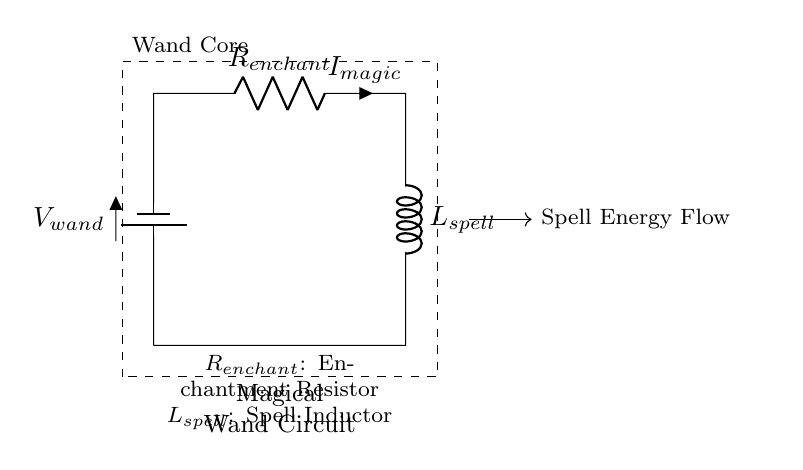What is the voltage source in this circuit? The voltage source is labeled as V_wand, which indicates it is providing the electrical potential to the circuit for creating magical effects.
Answer: V_wand What component is represented by R in the circuit? The component R is labeled as R_enchant, which denotes it as the Enchantment Resistor that contributes to the magical properties of the circuit.
Answer: R_enchant What is the current flowing through the resistor? The current flowing through the resistor is labeled as I_magic, indicating it is the current responsible for the enchanting effects within the wand.
Answer: I_magic What is the purpose of the inductor in this circuit? The inductor, labeled as L_spell, is used to store energy in the form of a magnetic field and release it subsequently, crucial for the functionality of magical spells.
Answer: L_spell How are the resistor and inductor connected in the circuit? The resistor R_enchant is connected in series with the inductor L_spell, creating a path for the current to flow and interact in a way that enables the special effects of the wand.
Answer: Series What is the total energy flow in the circuit represented by? The total energy flow is represented by the dashed arrow labeled as Spell Energy Flow, indicating the direction in which magical energy is transferred through the components.
Answer: Spell Energy Flow What does the rectangle enclosing the circuit indicate? The rectangle represents the Wand Core, which is the structural housing that contains and protects the internal components of the magical wand circuit.
Answer: Wand Core 